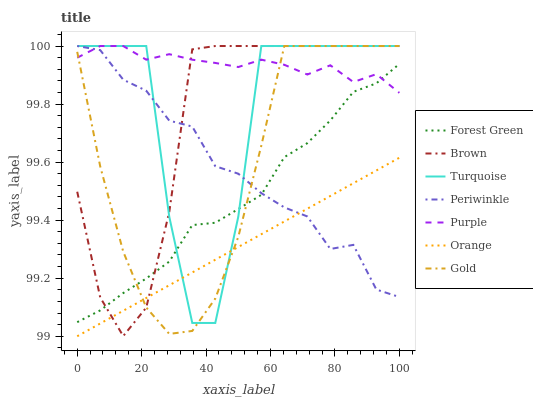Does Orange have the minimum area under the curve?
Answer yes or no. Yes. Does Purple have the maximum area under the curve?
Answer yes or no. Yes. Does Turquoise have the minimum area under the curve?
Answer yes or no. No. Does Turquoise have the maximum area under the curve?
Answer yes or no. No. Is Orange the smoothest?
Answer yes or no. Yes. Is Turquoise the roughest?
Answer yes or no. Yes. Is Gold the smoothest?
Answer yes or no. No. Is Gold the roughest?
Answer yes or no. No. Does Orange have the lowest value?
Answer yes or no. Yes. Does Turquoise have the lowest value?
Answer yes or no. No. Does Periwinkle have the highest value?
Answer yes or no. Yes. Does Forest Green have the highest value?
Answer yes or no. No. Is Orange less than Purple?
Answer yes or no. Yes. Is Purple greater than Orange?
Answer yes or no. Yes. Does Purple intersect Forest Green?
Answer yes or no. Yes. Is Purple less than Forest Green?
Answer yes or no. No. Is Purple greater than Forest Green?
Answer yes or no. No. Does Orange intersect Purple?
Answer yes or no. No. 